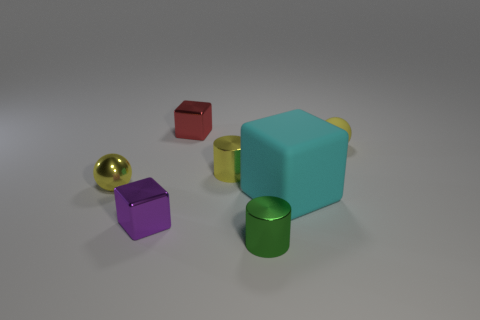How many objects are things in front of the yellow matte object or blocks that are behind the cyan object?
Your answer should be very brief. 6. Is the shiny sphere the same color as the small matte thing?
Ensure brevity in your answer.  Yes. Is the number of tiny yellow cylinders less than the number of small metal things?
Make the answer very short. Yes. There is a small green metal cylinder; are there any small shiny cylinders behind it?
Give a very brief answer. Yes. Is the material of the cyan thing the same as the green cylinder?
Give a very brief answer. No. There is another small object that is the same shape as the tiny green metal object; what is its color?
Your answer should be very brief. Yellow. There is a tiny cube that is behind the cyan matte object; is it the same color as the small metallic sphere?
Offer a very short reply. No. What shape is the small rubber thing that is the same color as the tiny shiny ball?
Your answer should be compact. Sphere. How many yellow cylinders have the same material as the green cylinder?
Offer a very short reply. 1. There is a small rubber object; how many small yellow metallic balls are behind it?
Ensure brevity in your answer.  0. 